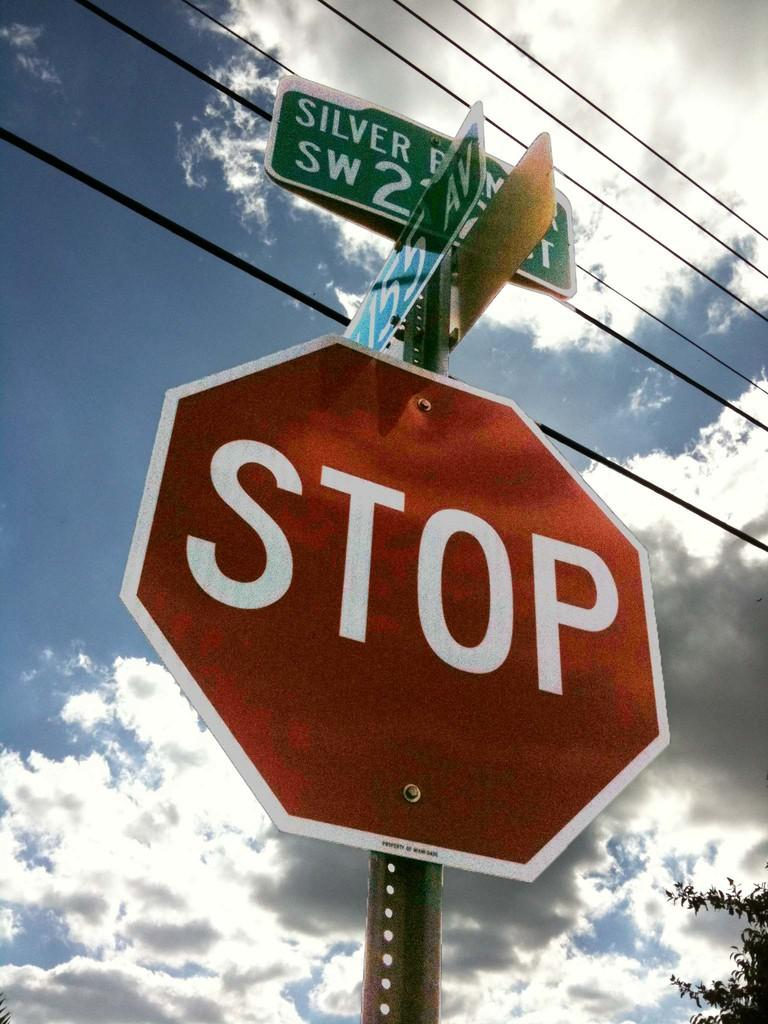<image>
Render a clear and concise summary of the photo. A hexagonal red stop sign is seen from below underneath a silver lined clouded sky. 